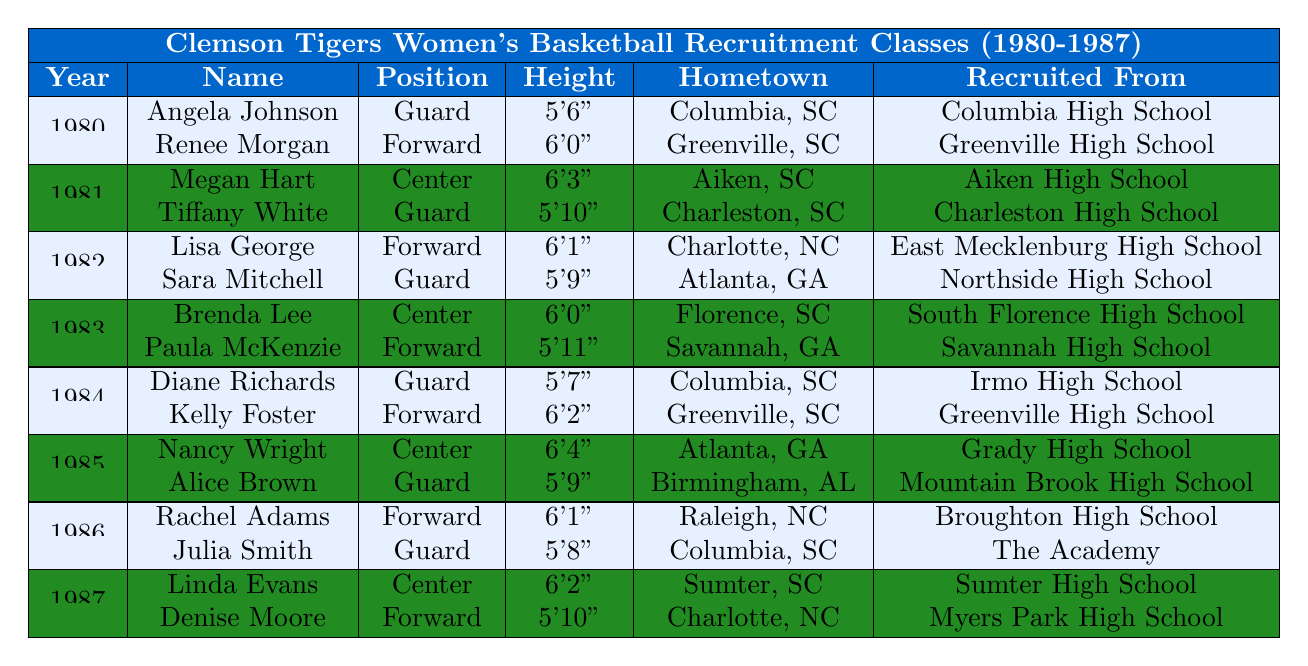What position did Megan Hart play? The table lists Megan Hart under the recruitment class of 1981, and the corresponding position is stated as "Center."
Answer: Center Which player from the 1980 recruitment class is from Greenville, SC? In the 1980 recruitment class, the player from Greenville, SC is Renee Morgan, as listed in the table.
Answer: Renee Morgan What is the height of Nancy Wright? The height of Nancy Wright is provided in the 1985 recruitment class as "6'4"."
Answer: 6'4" How many forwards were recruited in the year 1984? In the year 1984, the table lists two players: Diane Richards and Kelly Foster. Both are designated as "Guard" and "Forward", respectively, indicating one forward was recruited.
Answer: 1 True or False: All players in the 1981 class are from South Carolina. Megan Hart is from Aiken, SC, and Tiffany White is from Charleston, SC. Both players are indeed from South Carolina. Thus, the statement is true.
Answer: True In which year was the tallest recruited player and what is their height? The tallest player listed is Nancy Wright from the 1985 recruitment class, who is "6'4." This makes 1985 the year with the tallest recruited player.
Answer: 1985, 6'4 Which team consistently recruited players from Columbia, SC? The table shows that players from Columbia, SC, Angela Johnson (1980) and Julia Smith (1986) were both recruited, indicating a consistency of recruitment from this city for the Clemson Tigers.
Answer: Clemson Tigers How many players were recruited in total from 1980 to 1987? Each class consists of 2 players and there are 8 years from 1980 to 1987 (8 * 2 = 16).
Answer: 16 Which player from 1983 had the shortest height? The players from 1983 are Brenda Lee (6'0") and Paula McKenzie (5'11"). Paula McKenzie is the shorter of the two, with a height of 5'11".
Answer: Paula McKenzie Is there a player named Alice in the data? Alice Brown is listed in the 1985 recruitment class, confirming the existence of a player named Alice.
Answer: Yes What is the average height of the recruited players in 1986? The players in 1986 are Rachel Adams (6'1") and Julia Smith (5'8"). To find the average: (6'1" = 73 inches, 5'8" = 68 inches), hence the average height is (73 + 68) / 2 = 70.5 inches, equating to 5'10.5".
Answer: 5'10.5" 